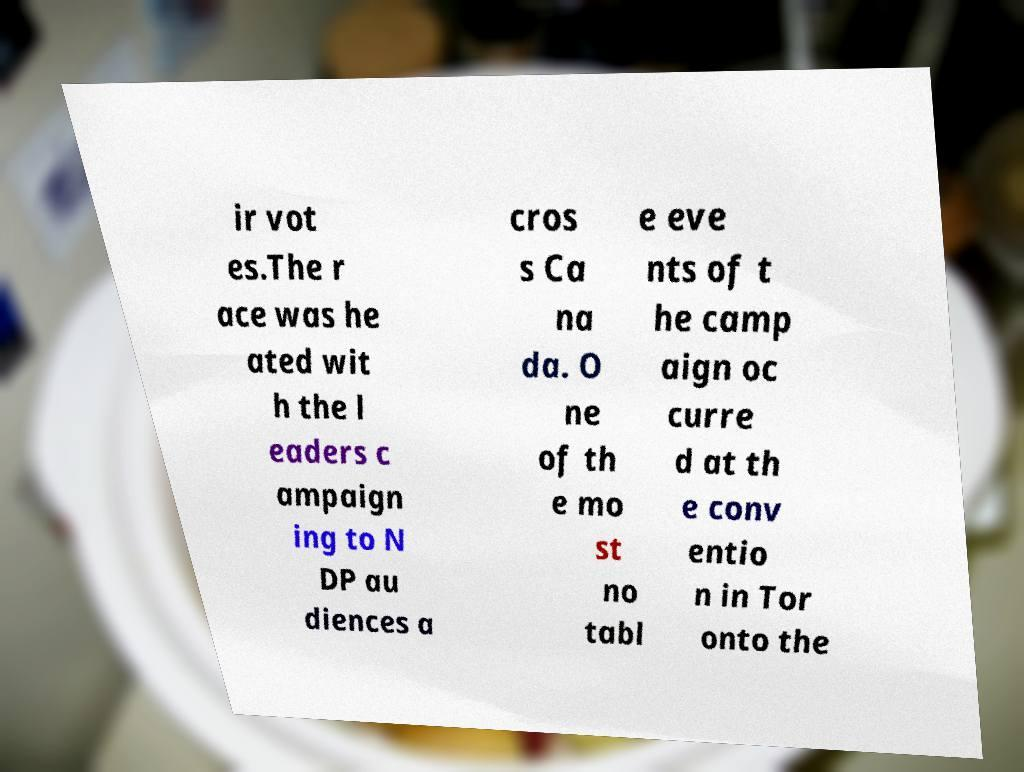Could you extract and type out the text from this image? ir vot es.The r ace was he ated wit h the l eaders c ampaign ing to N DP au diences a cros s Ca na da. O ne of th e mo st no tabl e eve nts of t he camp aign oc curre d at th e conv entio n in Tor onto the 